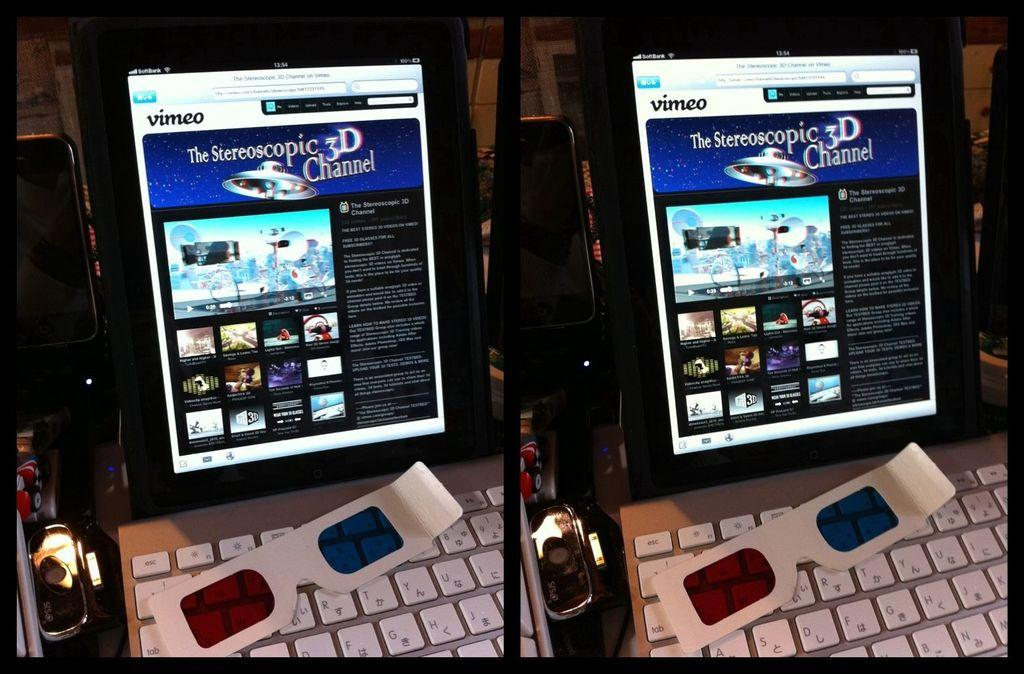<image>
Describe the image concisely. a 3D channel logo that is on the screen 